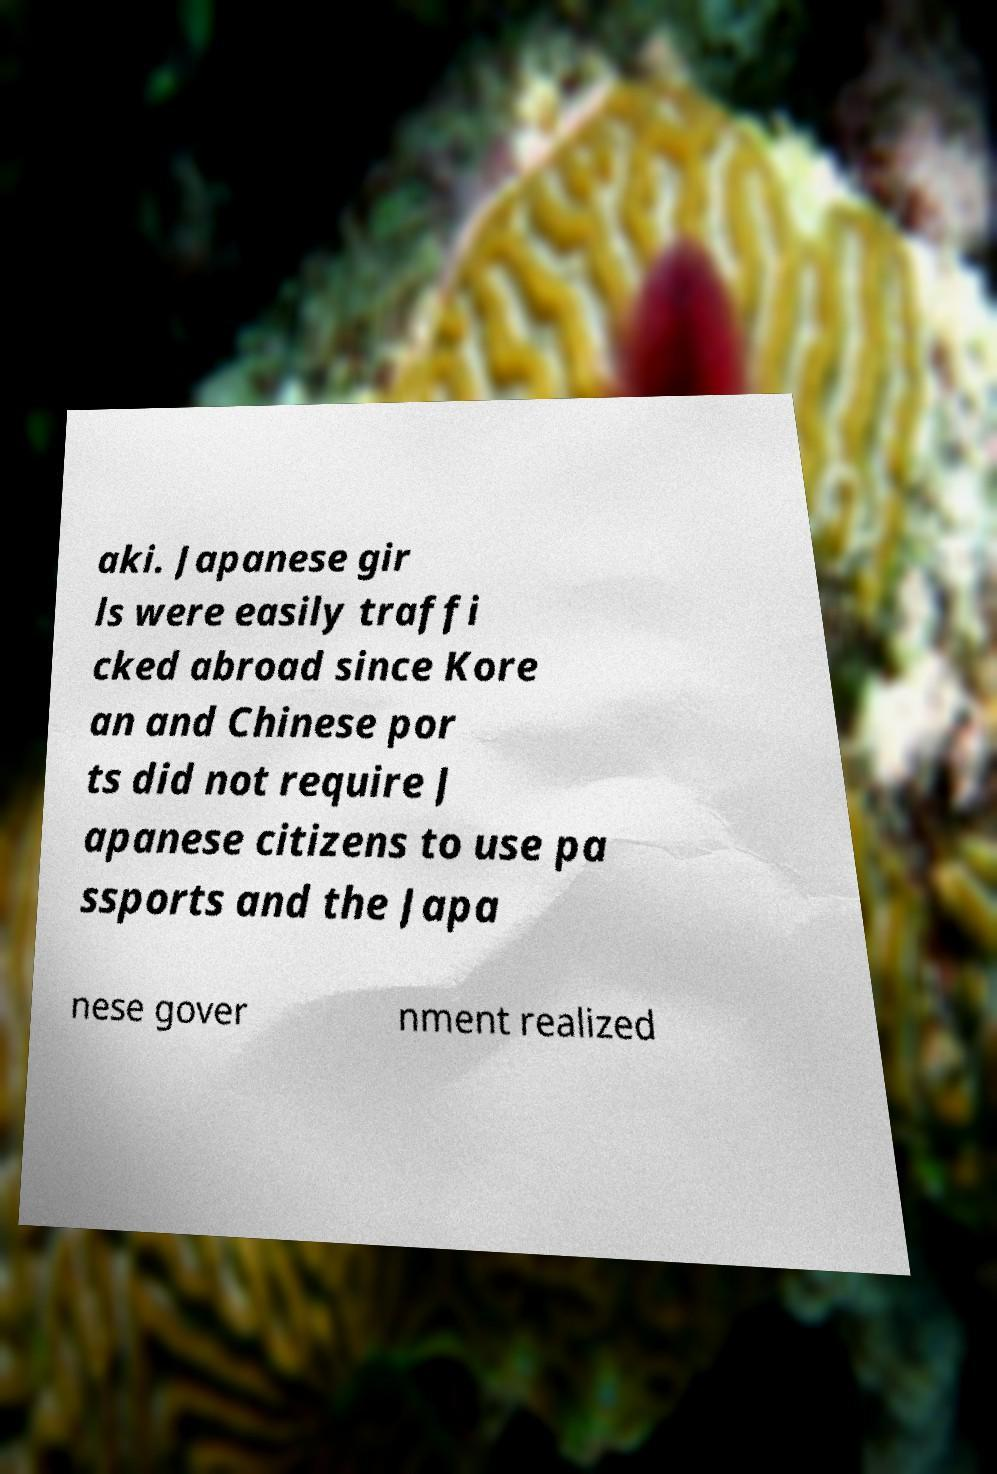What messages or text are displayed in this image? I need them in a readable, typed format. aki. Japanese gir ls were easily traffi cked abroad since Kore an and Chinese por ts did not require J apanese citizens to use pa ssports and the Japa nese gover nment realized 